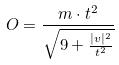<formula> <loc_0><loc_0><loc_500><loc_500>O = \frac { m \cdot t ^ { 2 } } { \sqrt { 9 + \frac { | v | ^ { 2 } } { t ^ { 2 } } } }</formula> 